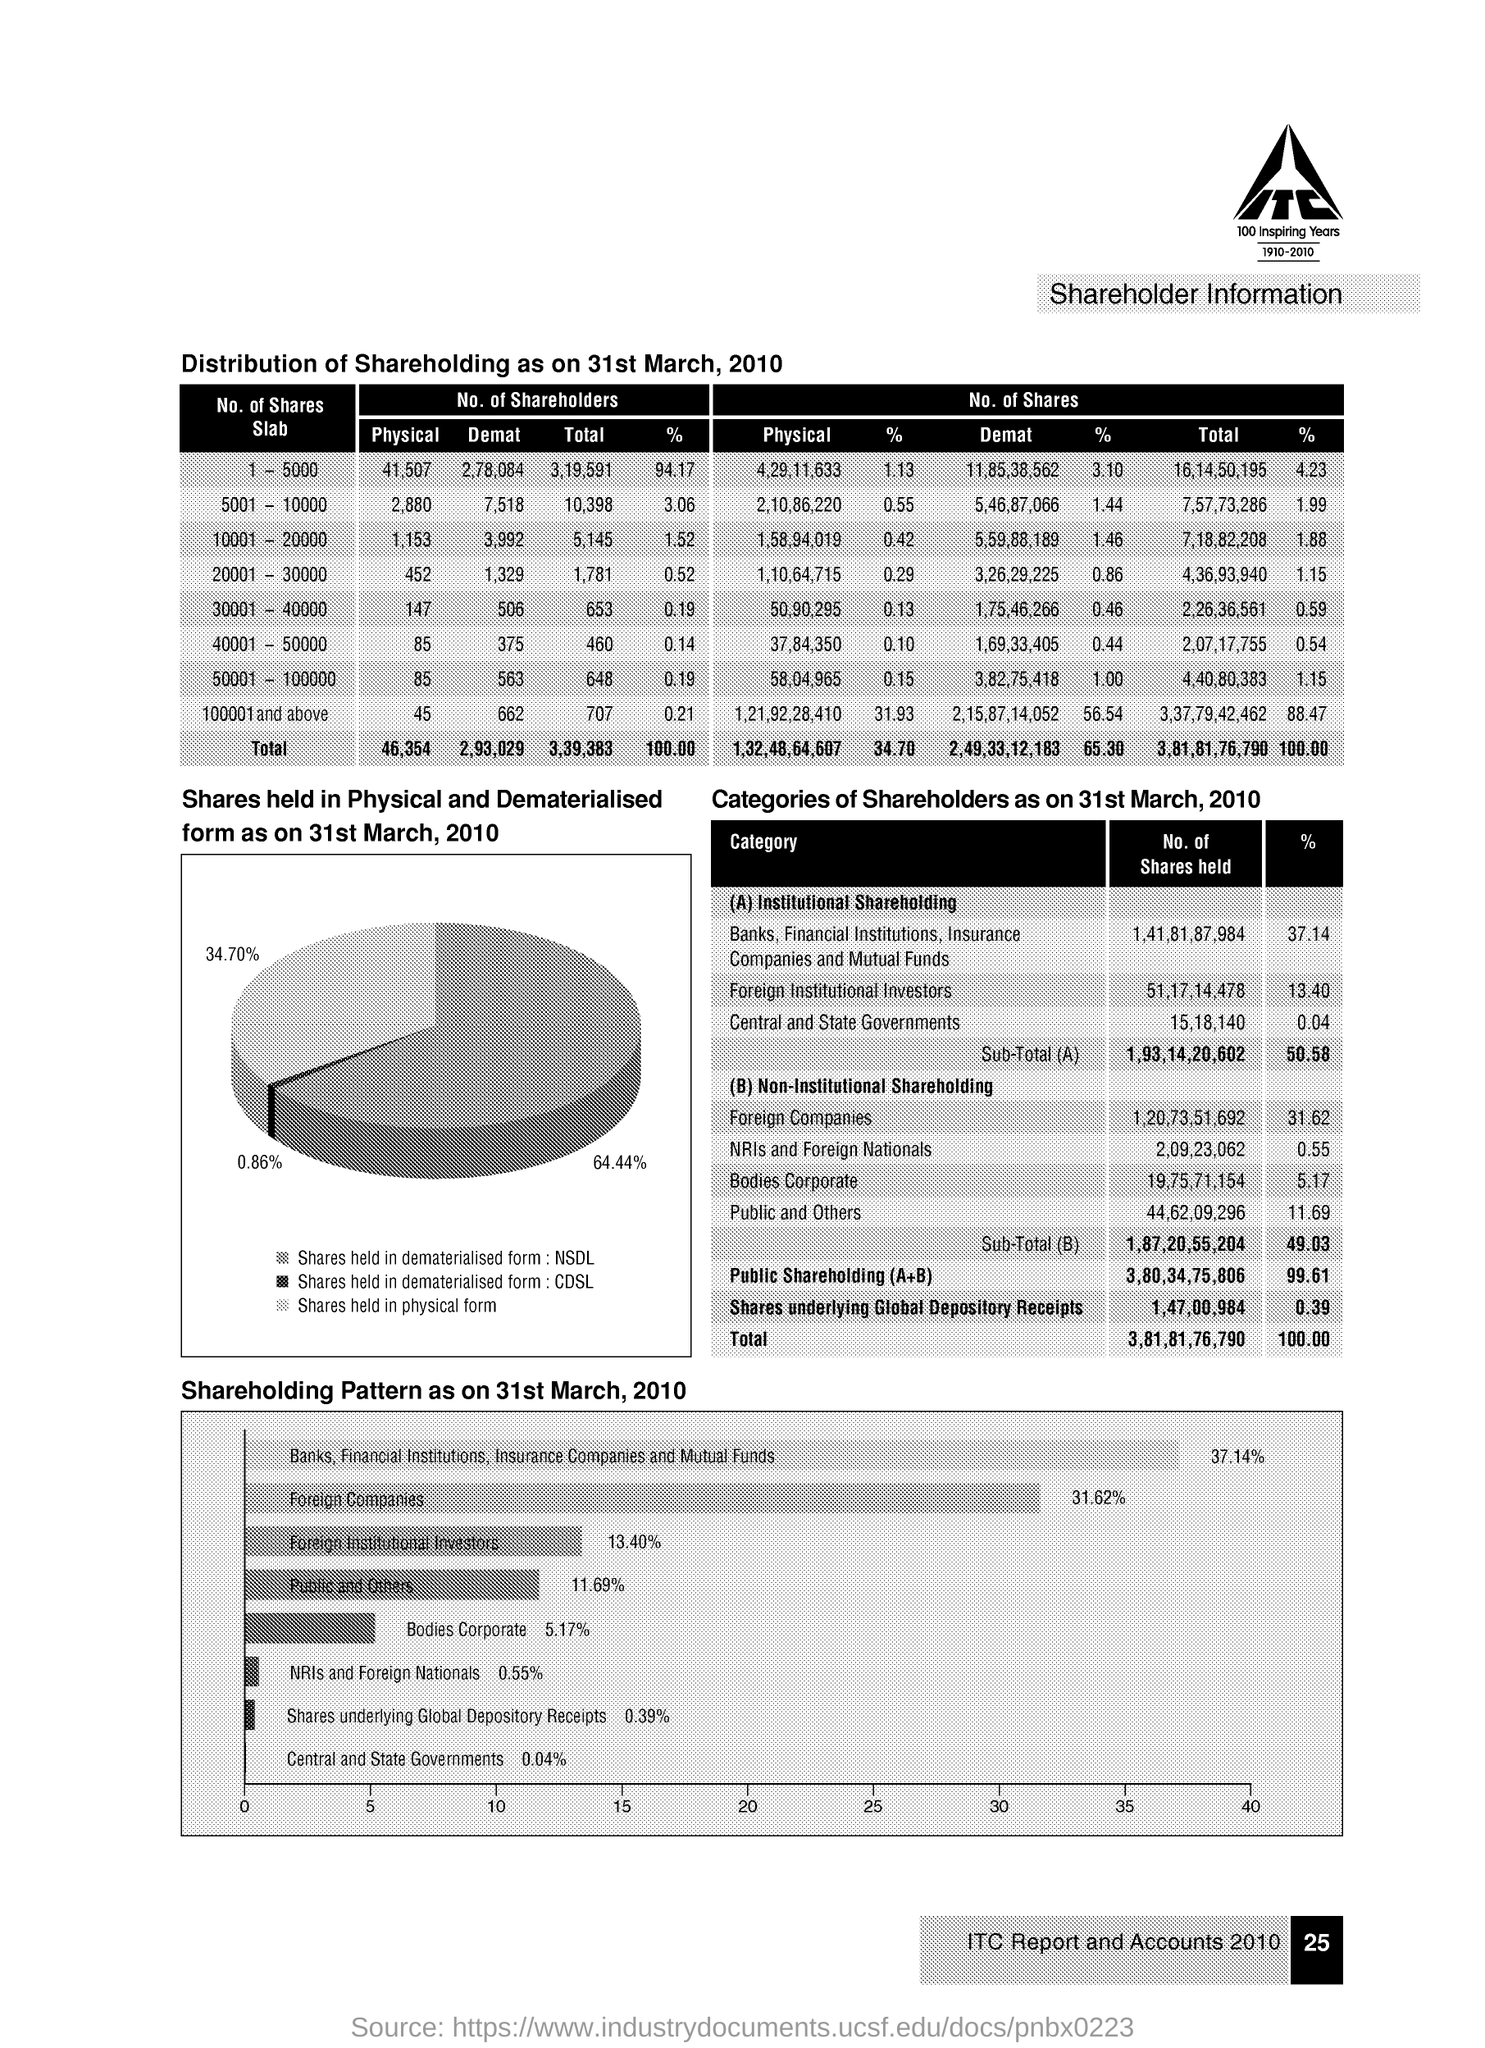What is the % of no of shares held in foreign institutional investors ?
Your answer should be very brief. 13.40 %. How many no of shares are held in central and state governments ?
Provide a short and direct response. 15,18,140. What is the % of no of shares held in banks,financial institutions,insurance companies and mutual funds ?
Provide a succinct answer. 37.14%. What is the % of shareholding of nris and foreign nationals as on march ,2010 ?
Provide a short and direct response. 0.55%. How many no of shares underlying global depository receipts ?
Ensure brevity in your answer.  1,47,00,984. What is the % of shares held in physical form as on 31st march ,2010 ?
Provide a succinct answer. 34.70%. What is the % of shares held in dematerialised form :cdsl as on 31st march ,2010 ?
Make the answer very short. 0.86%. What is the % of public and others shareholding pattern as on 31st march ,2010 ?
Offer a very short reply. 11.69%. What is the % of foreign companies shareholding pattern as on 31st march ,2010 ?
Offer a terse response. 31.62%. 